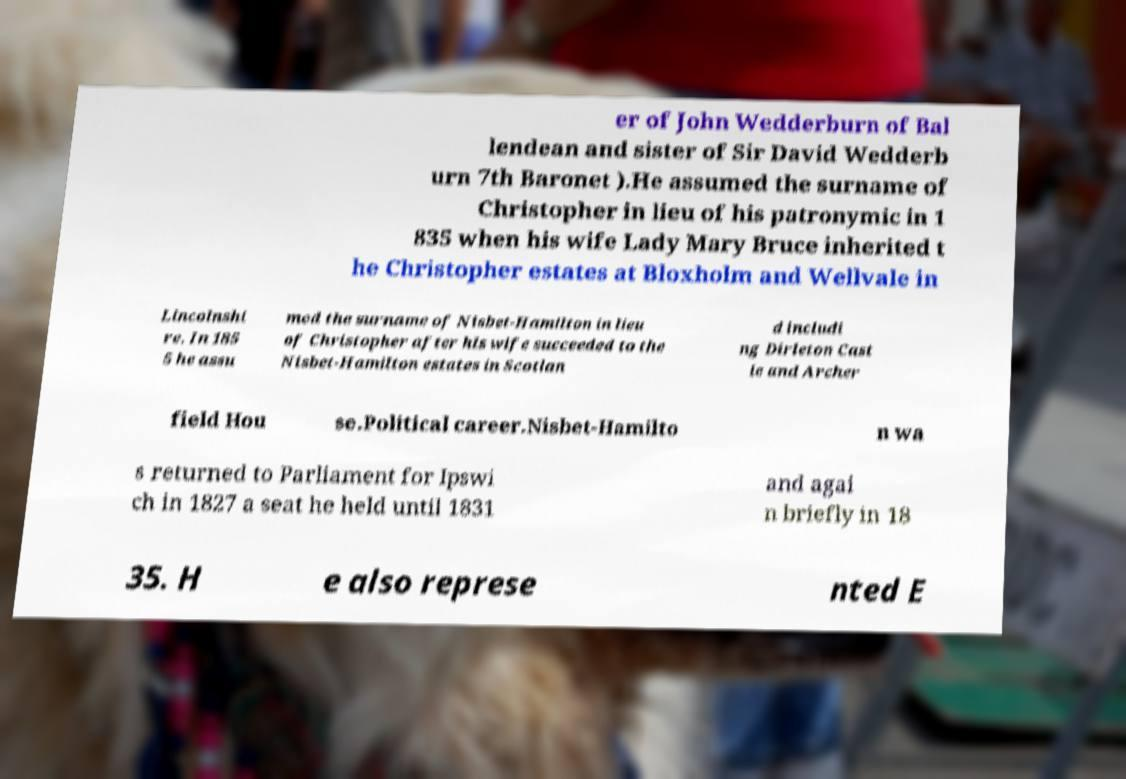Can you accurately transcribe the text from the provided image for me? er of John Wedderburn of Bal lendean and sister of Sir David Wedderb urn 7th Baronet ).He assumed the surname of Christopher in lieu of his patronymic in 1 835 when his wife Lady Mary Bruce inherited t he Christopher estates at Bloxholm and Wellvale in Lincolnshi re. In 185 5 he assu med the surname of Nisbet-Hamilton in lieu of Christopher after his wife succeeded to the Nisbet-Hamilton estates in Scotlan d includi ng Dirleton Cast le and Archer field Hou se.Political career.Nisbet-Hamilto n wa s returned to Parliament for Ipswi ch in 1827 a seat he held until 1831 and agai n briefly in 18 35. H e also represe nted E 